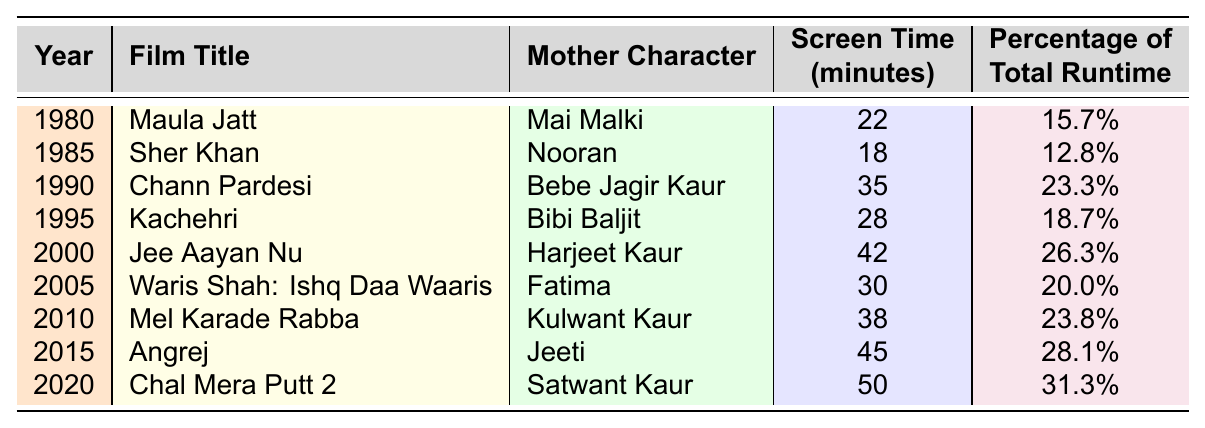What is the total screen time for mother characters in the film "Angrej"? According to the table, the screen time for the mother character "Jeeti" in the film "Angrej" is 45 minutes.
Answer: 45 minutes Which film has the highest percentage of total runtime for its mother character? The film "Chal Mera Putt 2" has the highest percentage of total runtime for its mother character, with a percentage of 31.3%.
Answer: Chal Mera Putt 2 How many minutes of screen time did mother characters have in the films from 1980 to 1995 combined? The total screen time from 1980 to 1995 is the sum of the screen times: 22 (Maula Jatt) + 18 (Sher Khan) + 35 (Chann Pardesi) + 28 (Kachehri) = 103 minutes.
Answer: 103 minutes What is the average screen time for mother characters across all films listed? To find the average, sum the screen times: 22 + 18 + 35 + 28 + 42 + 30 + 38 + 45 + 50 = 308 minutes. There are 9 films, so the average is 308/9 ≈ 34.2 minutes.
Answer: Approximately 34.2 minutes Did any film released after 2010 have less screen time for the mother character than any film released before 1995? Films released after 2010: "Angrej" (45 minutes) and "Chal Mera Putt 2" (50 minutes). The films before 1995 had screen times of 22 (Maula Jatt), 18 (Sher Khan), 35 (Chann Pardesi), and 28 (Kachehri). The maximum screen time for films before 1995 is 35 minutes, thus no film after 2010 had less screen time.
Answer: No Which mother character has the longest screen time in the table? The mother character "Satwant Kaur" from "Chal Mera Putt 2" has the longest screen time at 50 minutes.
Answer: Satwant Kaur What is the total screen time for mother characters from the 2000s (2000-2009)? The total screen time from 2000 to 2009 includes "Jee Aayan Nu" (42 minutes), "Waris Shah: Ishq Daa Waaris" (30 minutes), and "Mel Karade Rabba" (38 minutes). Adding these gives: 42 + 30 + 38 = 110 minutes.
Answer: 110 minutes Which character had a larger screen time: "Harjeet Kaur" from "Jee Aayan Nu" or "Nooran" from "Sher Khan"? "Harjeet Kaur" from "Jee Aayan Nu" had 42 minutes of screen time, while "Nooran" from "Sher Khan" had 18 minutes. Since 42 > 18, "Harjeet Kaur" had a larger screen time.
Answer: Harjeet Kaur Is the screen time for the mother character in "Jee Aayan Nu" less than 30 minutes? The screen time for "Harjeet Kaur" in "Jee Aayan Nu" is 42 minutes, which is greater than 30 minutes.
Answer: No What was the change in screen time for mother characters between the first film of the 1980s and the last film of the 2010s? The first film of the 1980s "Maula Jatt" has 22 minutes and the last film from the 2010s "Chal Mera Putt 2" has 50 minutes. The change is 50 - 22 = 28 minutes.
Answer: 28 minutes 